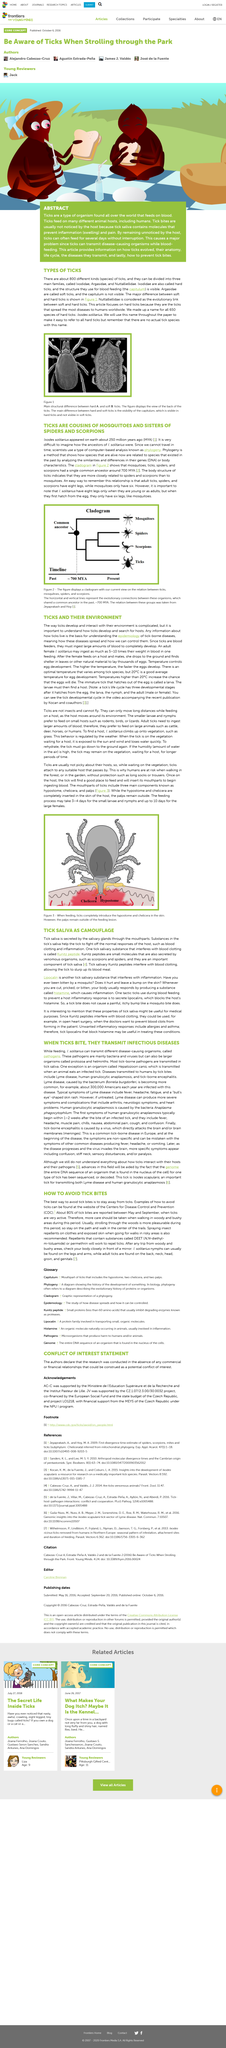Outline some significant characteristics in this image. The saliva of ticks is secreted by the salivary glands through their mouthparts. The three main families into which tick species can be grouped are Ixodidae, Argasidae, and Nuttalliellidae. Tick bites can be dangerous because they can transmit disease-causing organisms while feeding on the host's blood, thus putting the host at risk of contracting various illnesses. The host's blood is the preferred food source of ticks. The main difference between hard and soft ticks in their blood feeding structure is the presence or absence of a visible capitulum in their blood feeding structures. 